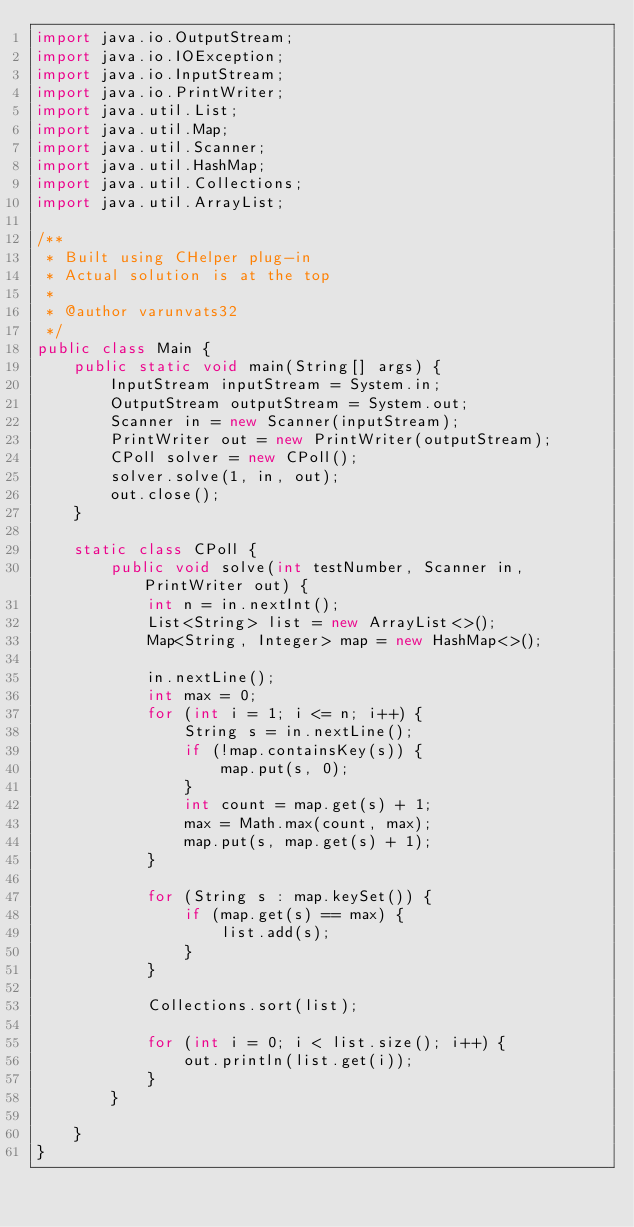<code> <loc_0><loc_0><loc_500><loc_500><_Java_>import java.io.OutputStream;
import java.io.IOException;
import java.io.InputStream;
import java.io.PrintWriter;
import java.util.List;
import java.util.Map;
import java.util.Scanner;
import java.util.HashMap;
import java.util.Collections;
import java.util.ArrayList;

/**
 * Built using CHelper plug-in
 * Actual solution is at the top
 *
 * @author varunvats32
 */
public class Main {
    public static void main(String[] args) {
        InputStream inputStream = System.in;
        OutputStream outputStream = System.out;
        Scanner in = new Scanner(inputStream);
        PrintWriter out = new PrintWriter(outputStream);
        CPoll solver = new CPoll();
        solver.solve(1, in, out);
        out.close();
    }

    static class CPoll {
        public void solve(int testNumber, Scanner in, PrintWriter out) {
            int n = in.nextInt();
            List<String> list = new ArrayList<>();
            Map<String, Integer> map = new HashMap<>();

            in.nextLine();
            int max = 0;
            for (int i = 1; i <= n; i++) {
                String s = in.nextLine();
                if (!map.containsKey(s)) {
                    map.put(s, 0);
                }
                int count = map.get(s) + 1;
                max = Math.max(count, max);
                map.put(s, map.get(s) + 1);
            }

            for (String s : map.keySet()) {
                if (map.get(s) == max) {
                    list.add(s);
                }
            }

            Collections.sort(list);

            for (int i = 0; i < list.size(); i++) {
                out.println(list.get(i));
            }
        }

    }
}

</code> 